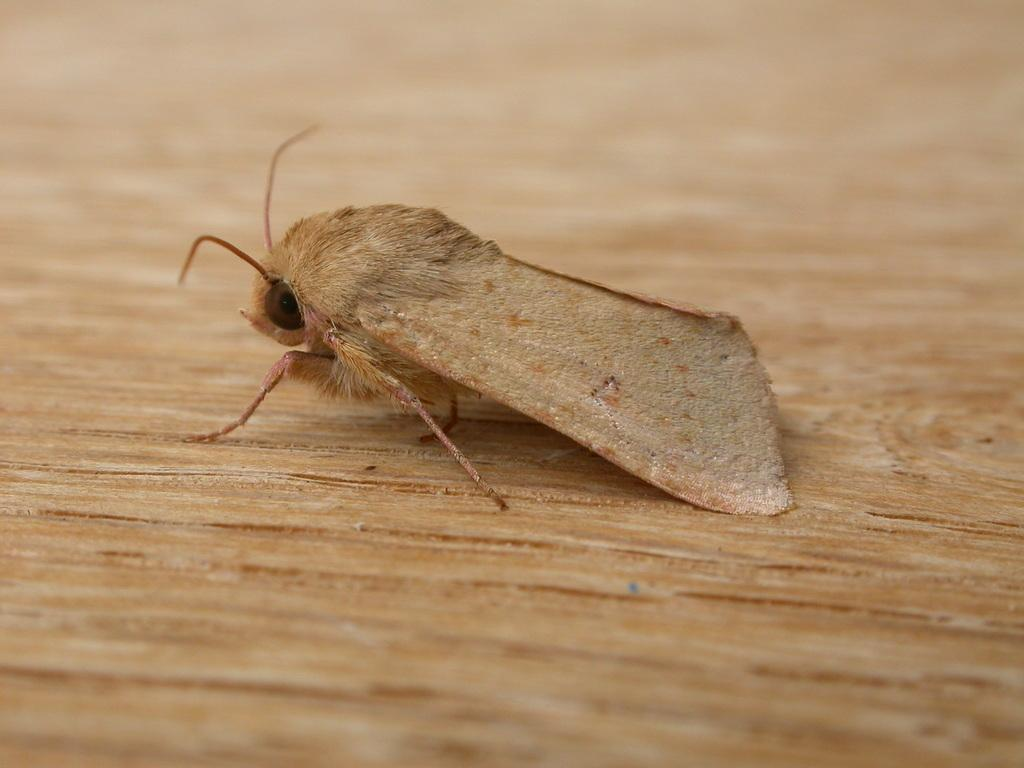What type of creature can be seen in the image? There is an insect in the image. What is the insect sitting on in the image? The insect is on a wooden surface. What type of legal advice can be provided by the insect in the image? The insect in the image is not a lawyer and cannot provide legal advice. 